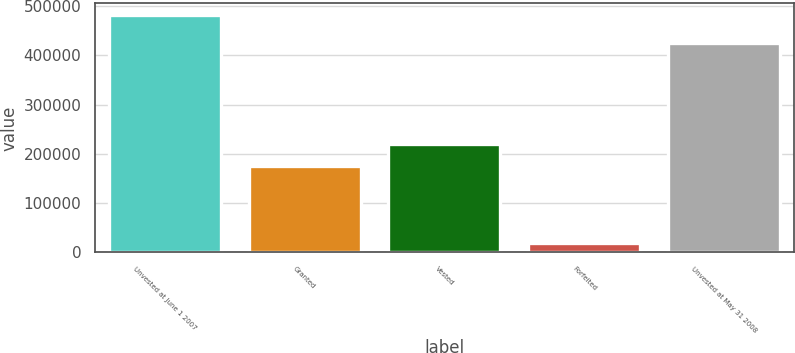Convert chart. <chart><loc_0><loc_0><loc_500><loc_500><bar_chart><fcel>Unvested at June 1 2007<fcel>Granted<fcel>Vested<fcel>Forfeited<fcel>Unvested at May 31 2008<nl><fcel>481347<fcel>174418<fcel>220686<fcel>18667<fcel>424985<nl></chart> 